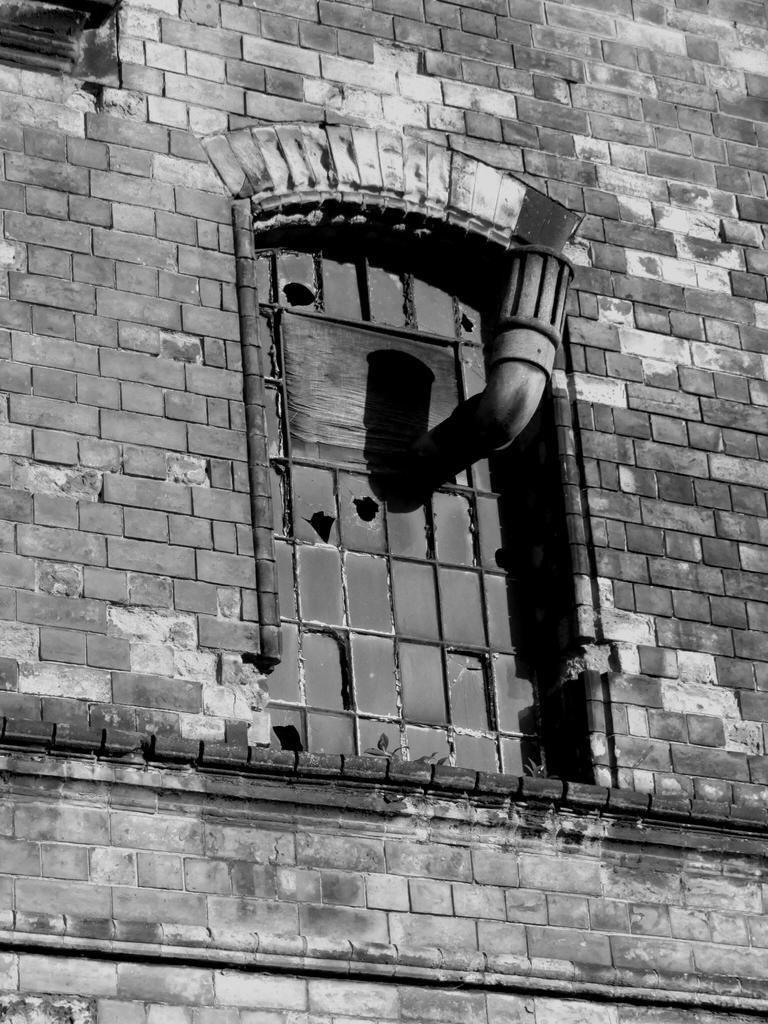What type of material is visible in the image? There is brick work in the image. What type of ear is visible in the image? There is no ear present in the image; it only features brick work. Can you tell me how many skates are shown in the image? There are no skates present in the image; it only features brick work. 